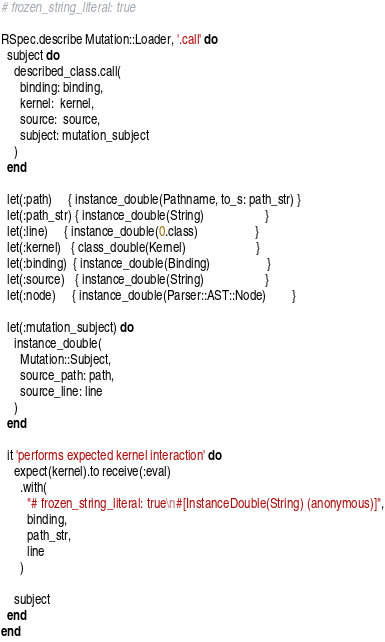Convert code to text. <code><loc_0><loc_0><loc_500><loc_500><_Ruby_># frozen_string_literal: true

RSpec.describe Mutation::Loader, '.call' do
  subject do
    described_class.call(
      binding: binding,
      kernel:  kernel,
      source:  source,
      subject: mutation_subject
    )
  end

  let(:path)     { instance_double(Pathname, to_s: path_str) }
  let(:path_str) { instance_double(String)                   }
  let(:line)     { instance_double(0.class)                  }
  let(:kernel)   { class_double(Kernel)                      }
  let(:binding)  { instance_double(Binding)                  }
  let(:source)   { instance_double(String)                   }
  let(:node)     { instance_double(Parser::AST::Node)        }

  let(:mutation_subject) do
    instance_double(
      Mutation::Subject,
      source_path: path,
      source_line: line
    )
  end

  it 'performs expected kernel interaction' do
    expect(kernel).to receive(:eval)
      .with(
        "# frozen_string_literal: true\n#[InstanceDouble(String) (anonymous)]",
        binding,
        path_str,
        line
      )

    subject
  end
end
</code> 